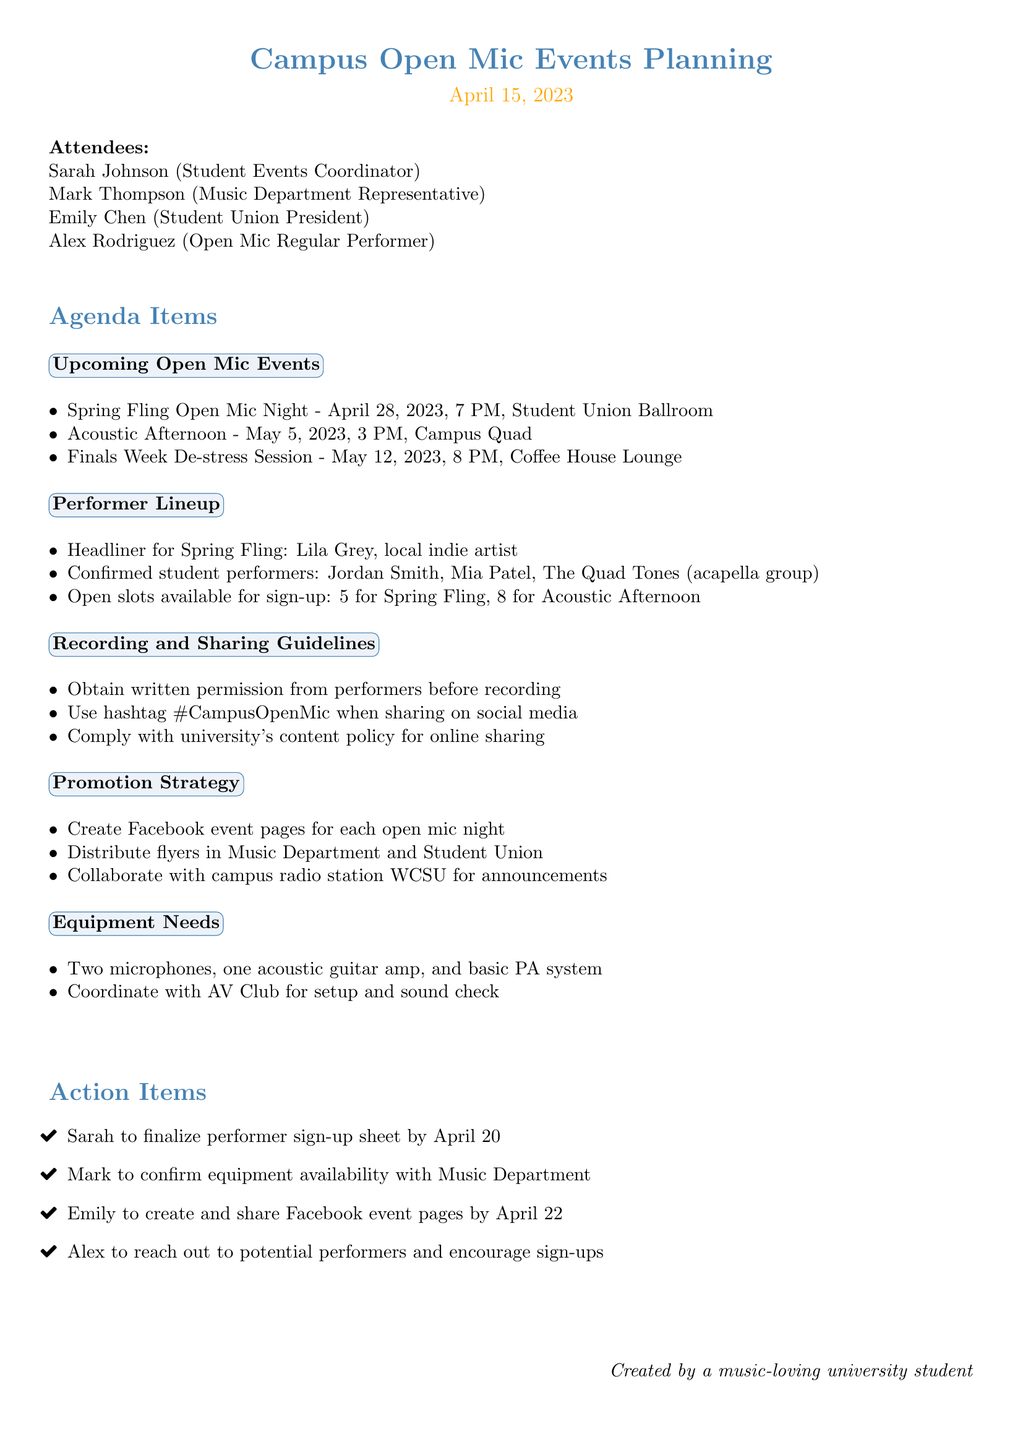What is the date of the Spring Fling Open Mic Night? The document states that the Spring Fling Open Mic Night is scheduled for April 28, 2023.
Answer: April 28, 2023 Who is the headliner for the Spring Fling? According to the document, Lila Grey is the headliner for the Spring Fling Open Mic Night.
Answer: Lila Grey How many confirmed student performers are there? The document lists three confirmed student performers: Jordan Smith, Mia Patel, and The Quad Tones.
Answer: Three What is the total number of open slots for the Acoustic Afternoon? The document indicates that there are 8 open slots available for sign-up for the Acoustic Afternoon event.
Answer: 8 Who is responsible for creating the Facebook event pages? The document states that Emily is tasked with creating and sharing Facebook event pages by April 22.
Answer: Emily What equipment needs to be coordinated with the AV Club? The document specifies that two microphones, one acoustic guitar amp, and a basic PA system need to be coordinated with the AV Club.
Answer: Equipment coordination How many events are listed in the Upcoming Open Mic Events section? The document lists three events under the Upcoming Open Mic Events section.
Answer: Three What is the hashtag to use when sharing on social media? The document mentions that the hashtag to use when sharing is #CampusOpenMic.
Answer: #CampusOpenMic What is the purpose of the Finals Week De-stress Session? The document details this as an event aimed at helping students de-stress during finals week.
Answer: De-stress session 